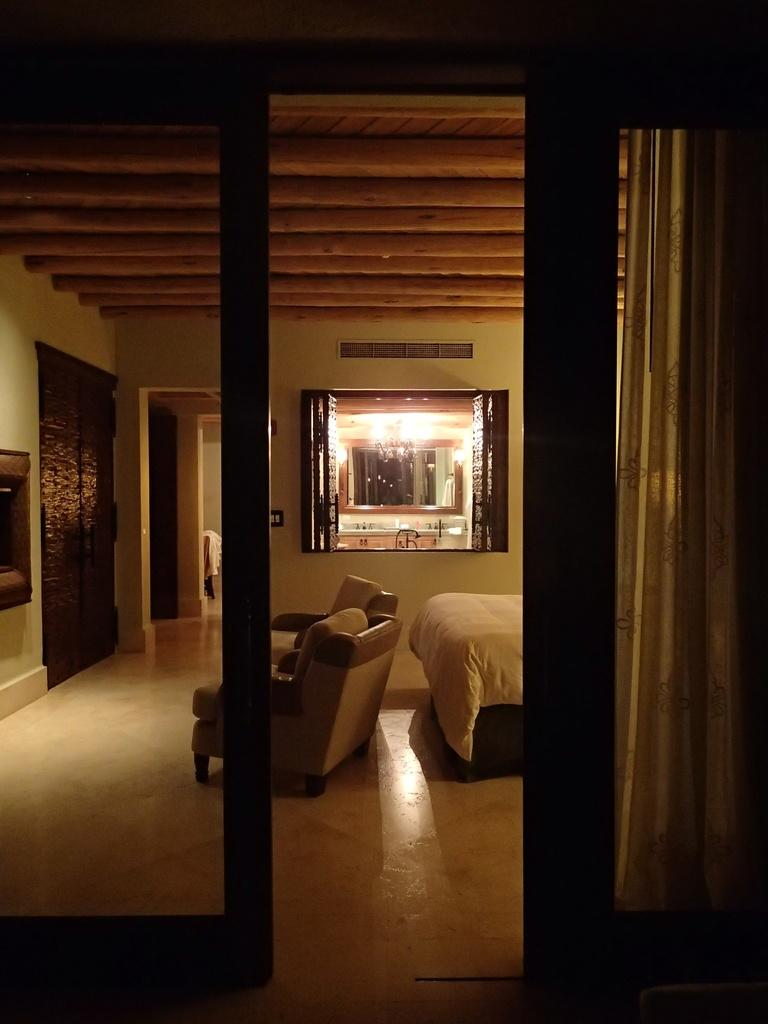What type of covering is on the right side of the image? There is a curtain on the right side of the image. What type of furniture is in the image? There is a bed and a sofa in the image. What can be seen in the background of the image? There is a window visible in the background of the image. Can you see any lakes or monkeys in the image? No, there are no lakes or monkeys present in the image. Is there a robin perched on the curtain in the image? No, there is no robin present in the image. 